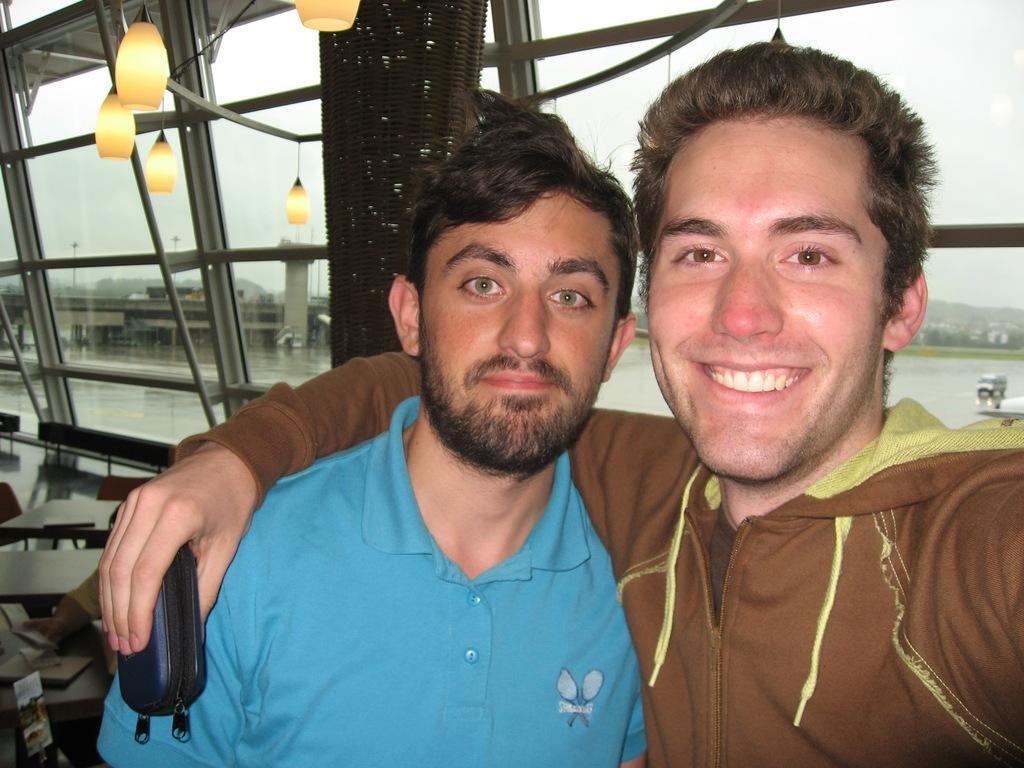Describe this image in one or two sentences. In this image there are two men standing. They are smiling. To the left there are tables and chairs. There are lamps hanging. Behind them there is a glass wall. Outside the wall there buildings and trees. At the top there is the sky. 